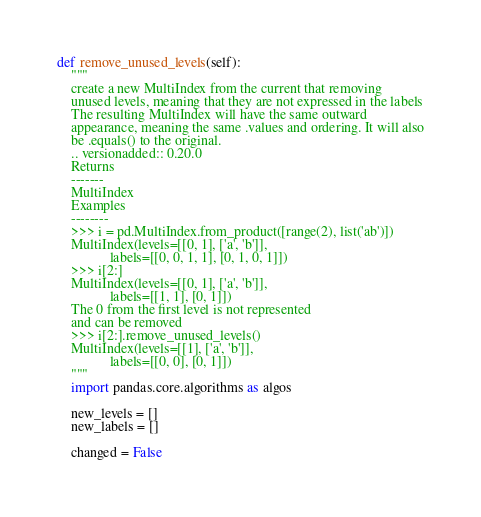<code> <loc_0><loc_0><loc_500><loc_500><_Python_>def remove_unused_levels(self):
    """
    create a new MultiIndex from the current that removing
    unused levels, meaning that they are not expressed in the labels
    The resulting MultiIndex will have the same outward
    appearance, meaning the same .values and ordering. It will also
    be .equals() to the original.
    .. versionadded:: 0.20.0
    Returns
    -------
    MultiIndex
    Examples
    --------
    >>> i = pd.MultiIndex.from_product([range(2), list('ab')])
    MultiIndex(levels=[[0, 1], ['a', 'b']],
               labels=[[0, 0, 1, 1], [0, 1, 0, 1]])
    >>> i[2:]
    MultiIndex(levels=[[0, 1], ['a', 'b']],
               labels=[[1, 1], [0, 1]])
    The 0 from the first level is not represented
    and can be removed
    >>> i[2:].remove_unused_levels()
    MultiIndex(levels=[[1], ['a', 'b']],
               labels=[[0, 0], [0, 1]])
    """
    import pandas.core.algorithms as algos

    new_levels = []
    new_labels = []

    changed = False</code> 